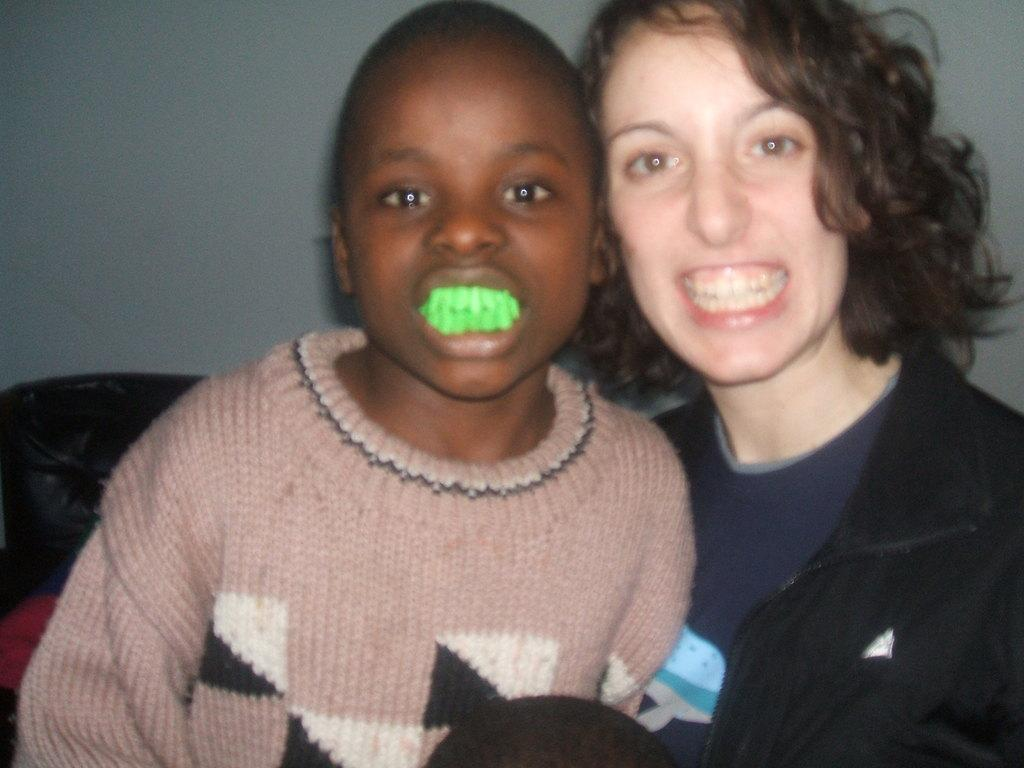Who are the people in the image? There is a lady and a boy in the image. What is the boy wearing that is green-colored? The boy is wearing a green-colored tooth. What can be seen behind the people in the image? The background of the image is a wall. What type of popcorn is the lady eating in the image? There is no popcorn present in the image. Does the boy seem to hate the lady in the image? There is no indication of the boy's feelings towards the lady in the image. What is the lady doing that makes the boy laugh in the image? There is no indication of the lady doing anything that would make the boy laugh in the image. 